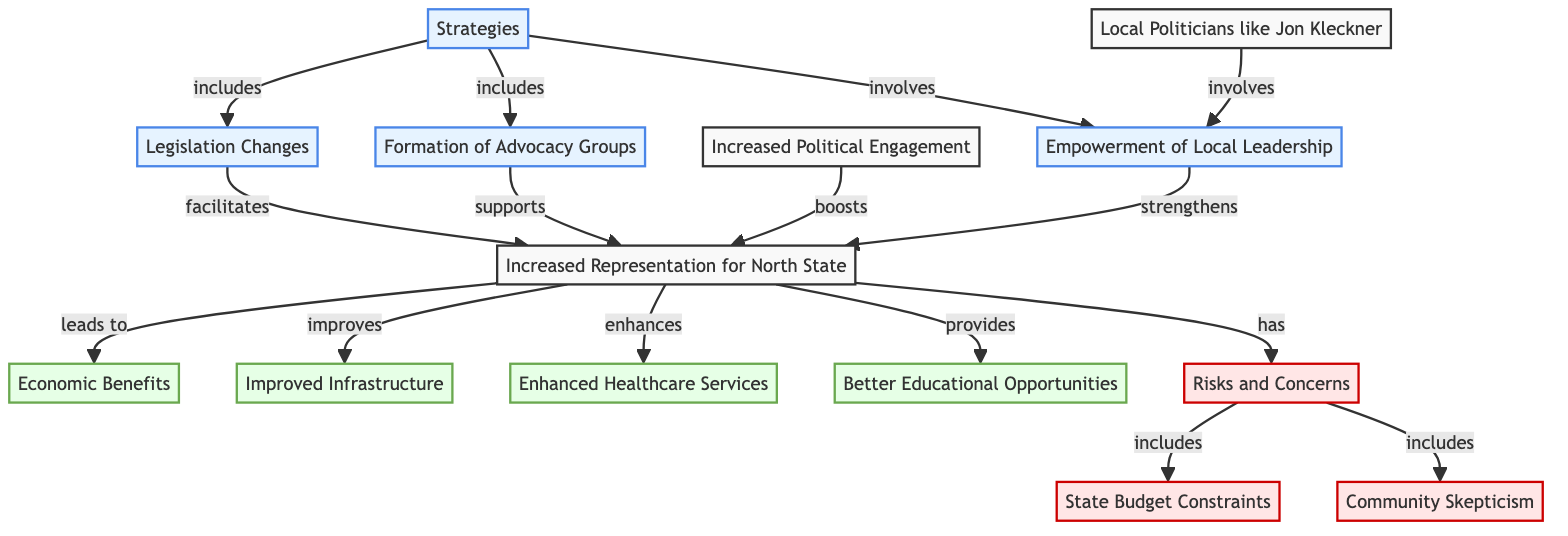What's the total number of nodes in the diagram? The total number of nodes can be found by counting all unique entities in the diagram. There are 13 nodes listed, from "Increased Representation for North State" to "Community Skepticism."
Answer: 13 What does "Legislation Changes" support? The relationship shown in the diagram indicates that "Legislation Changes" facilitates "Increased Representation for North State." This means that legislation changes are a necessary support to increase representation.
Answer: Increased Representation for North State Which node is color-coded as a risk in the diagram? In the diagram, nodes associated with risks are colored differently. "Risks and Concerns" is marked as a risk and is connected to both "State Budget Constraints" and "Community Skepticism."
Answer: Risks and Concerns How does "Increased Political Engagement" relate to "Increased Representation for North State"? The diagram shows an arrow from "Increased Political Engagement" to "Increased Representation for North State," indicating that increased political engagement boosts increased representation.
Answer: boosts What are the two types of benefits that "Increased Representation for North State" provides? The diagram connects "Increased Representation for North State" to several benefits, two of which are "Economic Benefits" and "Better Educational Opportunities." Both are directly identified as outcomes of increased representation.
Answer: Economic Benefits, Better Educational Opportunities What is one of the strategies that includes the formation of advocacy groups? The node "Strategies" has an arrow pointing to "Formation of Advocacy Groups" which indicates that advocacy groups are a part of the strategies aimed at increasing representation.
Answer: Strategies Which local politician is mentioned in the context of empowering local leadership? The diagram specifies "Local Politicians like Jon Kleckner" involving "Empowerment of Local Leadership," suggesting that Jon Kleckner plays a role in local leadership dynamics.
Answer: Jon Kleckner What concerns are included under "Risks and Concerns"? The diagram shows an arrow from "Risks and Concerns" to both "State Budget Constraints" and "Community Skepticism," suggesting these are part of the concerns reflected in the risks associated with increased representation.
Answer: State Budget Constraints, Community Skepticism How is "Improved Infrastructure" connected to "Increased Representation"? The arrow from "Increased Representation for North State" to "Improved Infrastructure" indicates that improvements in representation are believed to lead to improvements in infrastructure.
Answer: improves 